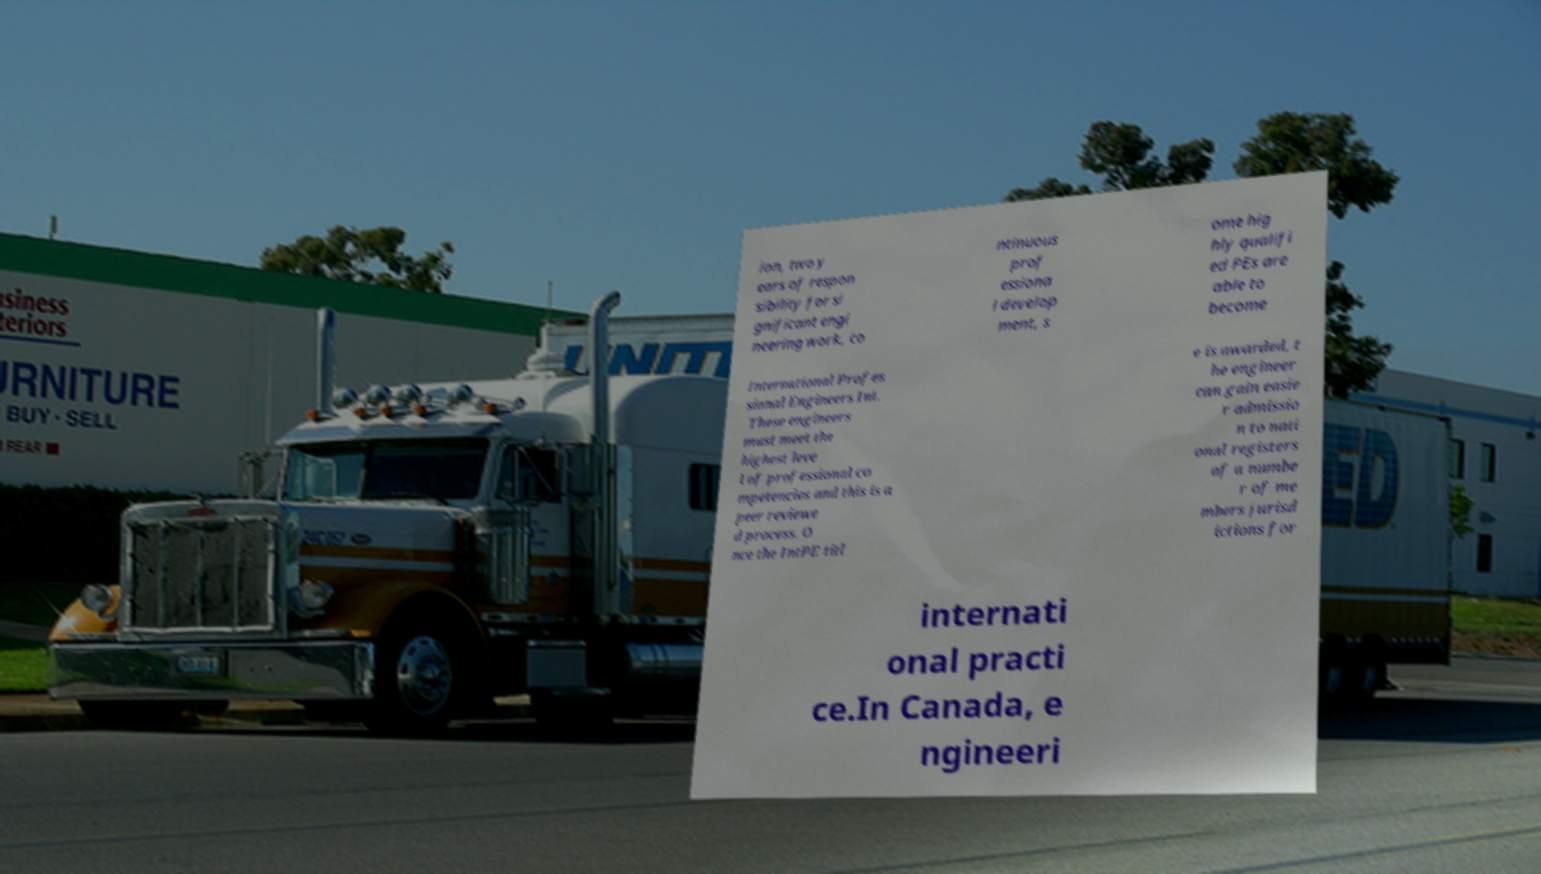Can you accurately transcribe the text from the provided image for me? ion, two y ears of respon sibility for si gnificant engi neering work, co ntinuous prof essiona l develop ment, s ome hig hly qualifi ed PEs are able to become International Profes sional Engineers Int. These engineers must meet the highest leve l of professional co mpetencies and this is a peer reviewe d process. O nce the IntPE titl e is awarded, t he engineer can gain easie r admissio n to nati onal registers of a numbe r of me mbers jurisd ictions for internati onal practi ce.In Canada, e ngineeri 